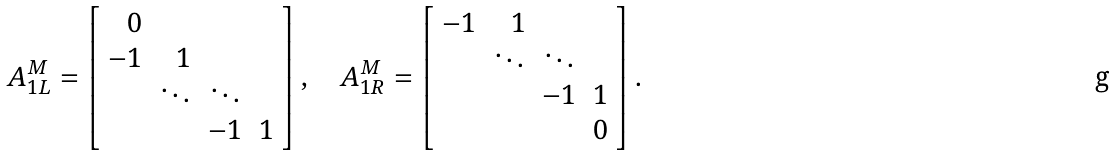<formula> <loc_0><loc_0><loc_500><loc_500>A _ { 1 L } ^ { M } = \left [ \begin{array} { r r r r } 0 \\ - 1 & 1 \\ & \ddots & \ddots \\ & & - 1 & 1 \end{array} \right ] , \quad A _ { 1 R } ^ { M } = \left [ \begin{array} { r r r r } - 1 & 1 \\ & \ddots & \ddots \\ & & - 1 & 1 \\ & & & 0 \end{array} \right ] .</formula> 